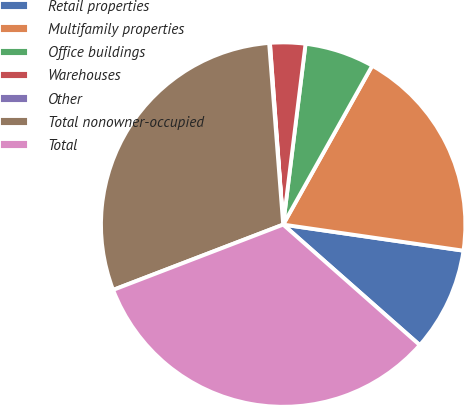<chart> <loc_0><loc_0><loc_500><loc_500><pie_chart><fcel>Retail properties<fcel>Multifamily properties<fcel>Office buildings<fcel>Warehouses<fcel>Other<fcel>Total nonowner-occupied<fcel>Total<nl><fcel>9.22%<fcel>19.16%<fcel>6.17%<fcel>3.12%<fcel>0.07%<fcel>29.61%<fcel>32.66%<nl></chart> 